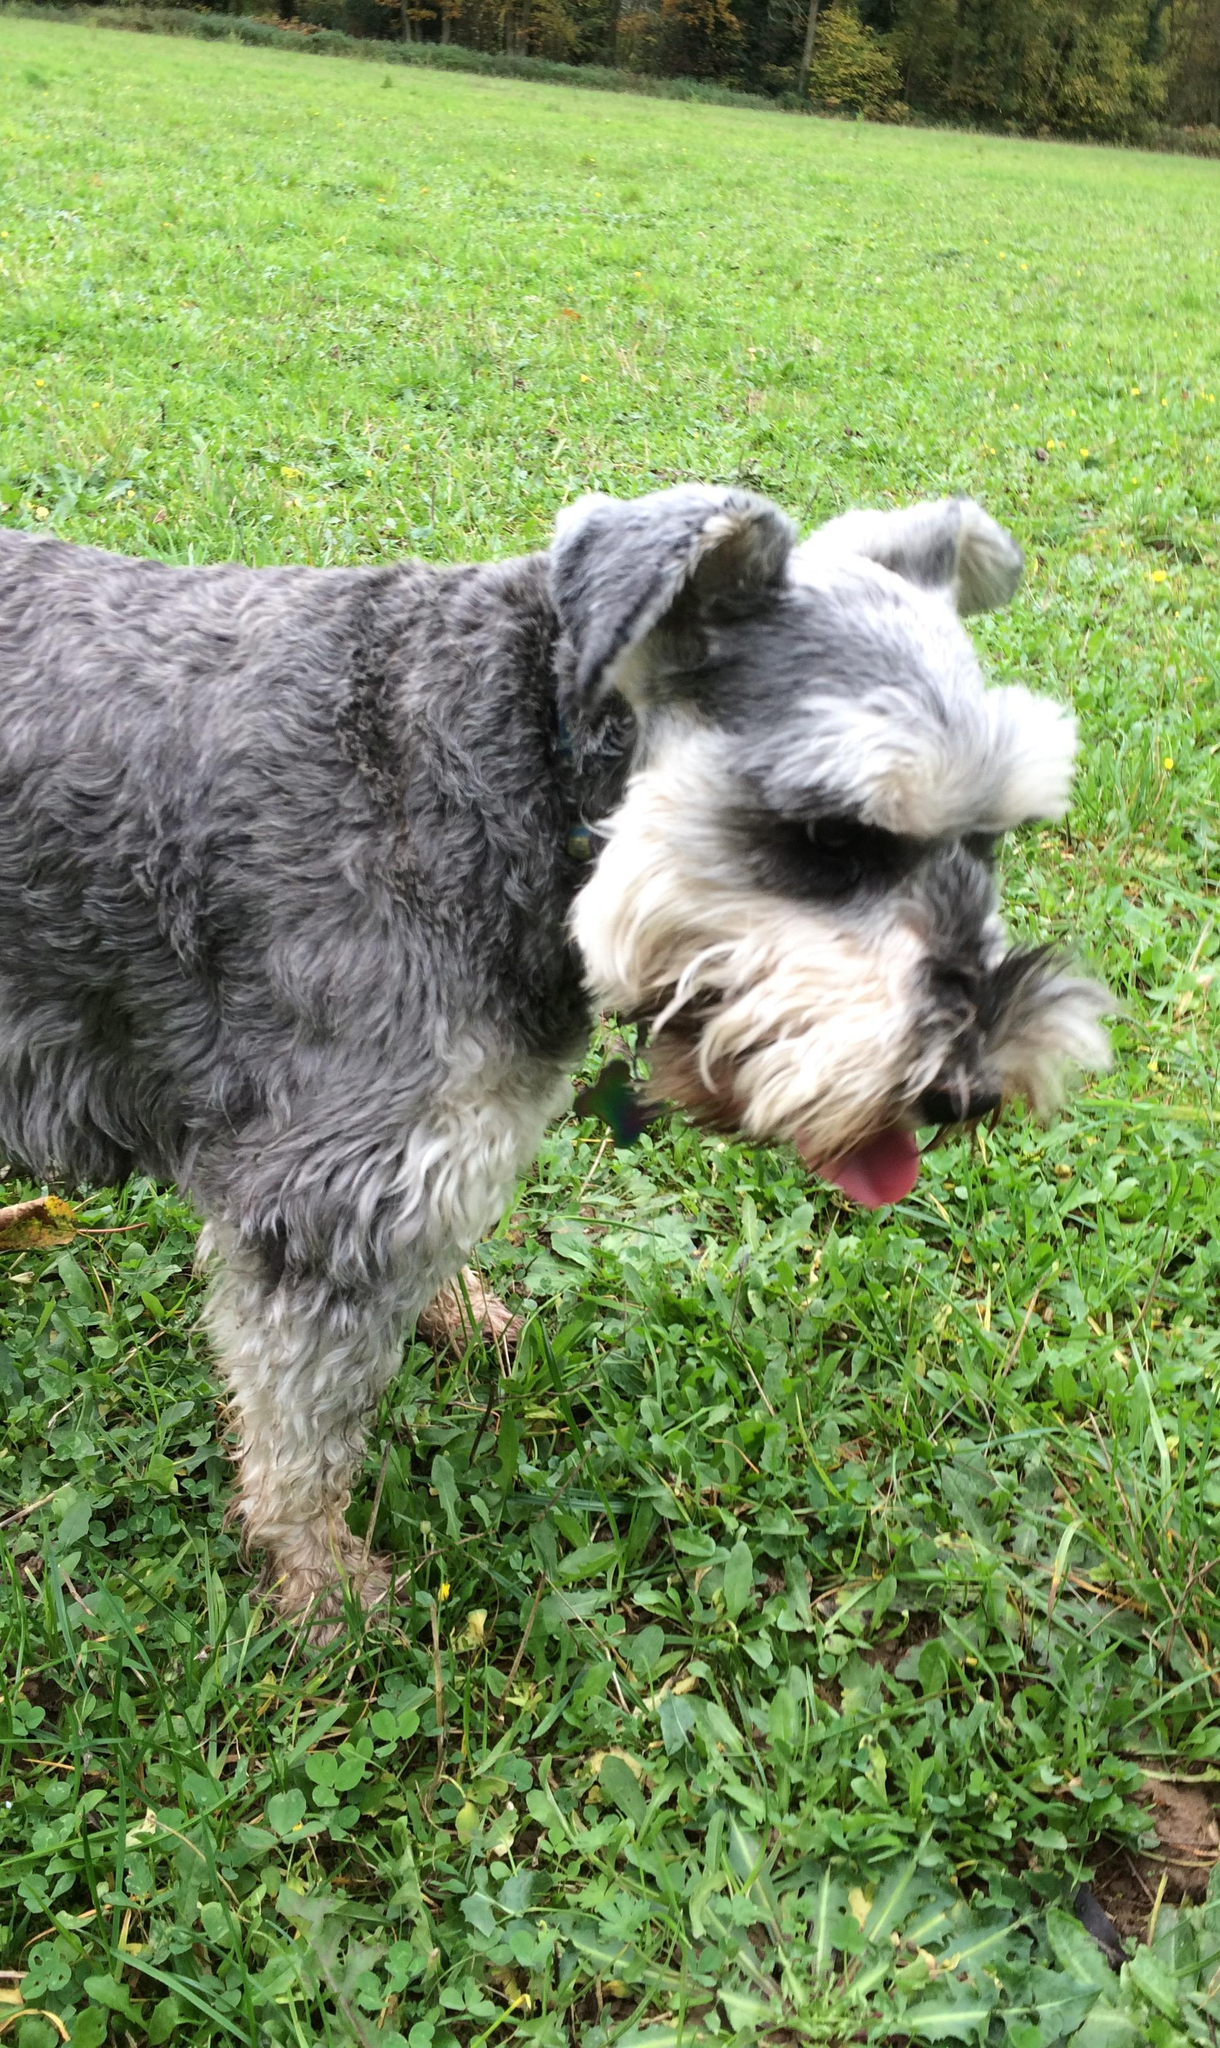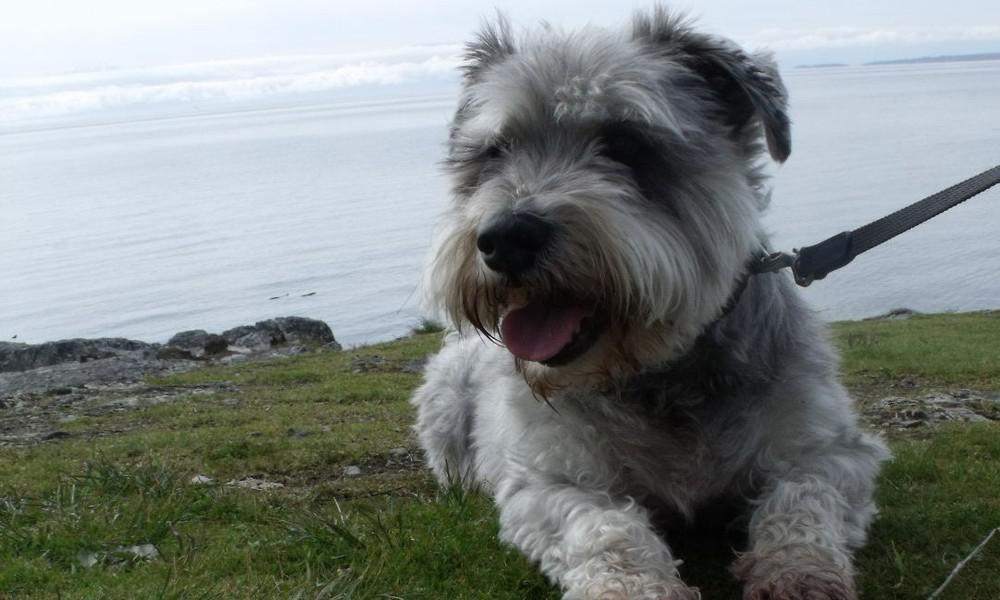The first image is the image on the left, the second image is the image on the right. For the images shown, is this caption "One image has more than one dog." true? Answer yes or no. No. 